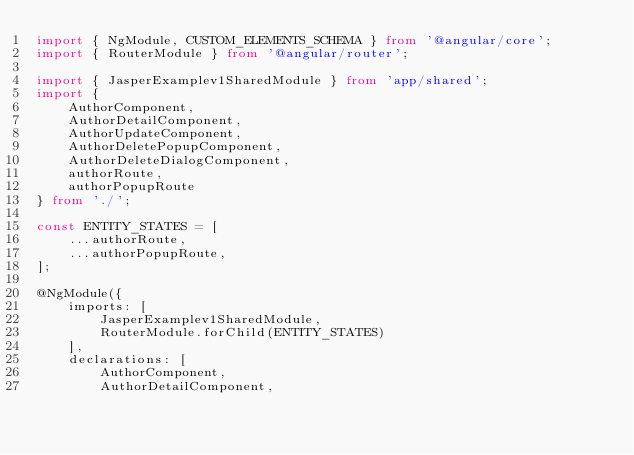<code> <loc_0><loc_0><loc_500><loc_500><_TypeScript_>import { NgModule, CUSTOM_ELEMENTS_SCHEMA } from '@angular/core';
import { RouterModule } from '@angular/router';

import { JasperExamplev1SharedModule } from 'app/shared';
import {
    AuthorComponent,
    AuthorDetailComponent,
    AuthorUpdateComponent,
    AuthorDeletePopupComponent,
    AuthorDeleteDialogComponent,
    authorRoute,
    authorPopupRoute
} from './';

const ENTITY_STATES = [
    ...authorRoute,
    ...authorPopupRoute,
];

@NgModule({
    imports: [
        JasperExamplev1SharedModule,
        RouterModule.forChild(ENTITY_STATES)
    ],
    declarations: [
        AuthorComponent,
        AuthorDetailComponent,</code> 